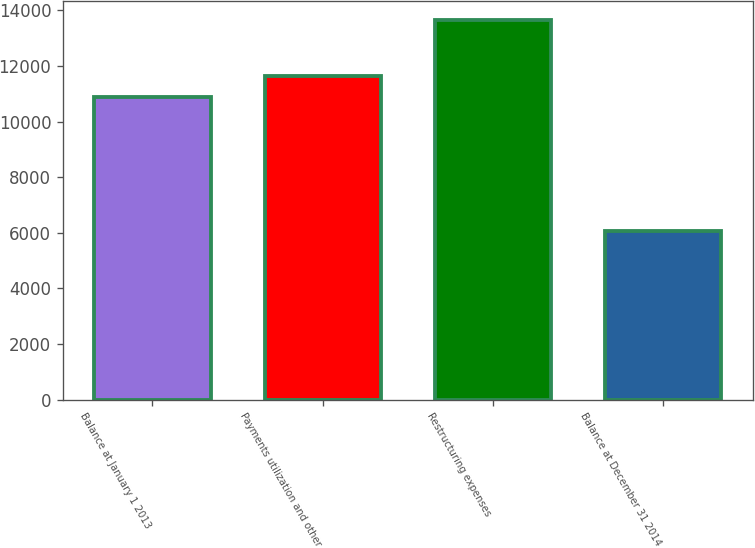Convert chart. <chart><loc_0><loc_0><loc_500><loc_500><bar_chart><fcel>Balance at January 1 2013<fcel>Payments utilization and other<fcel>Restructuring expenses<fcel>Balance at December 31 2014<nl><fcel>10887<fcel>11648.6<fcel>13672<fcel>6056<nl></chart> 